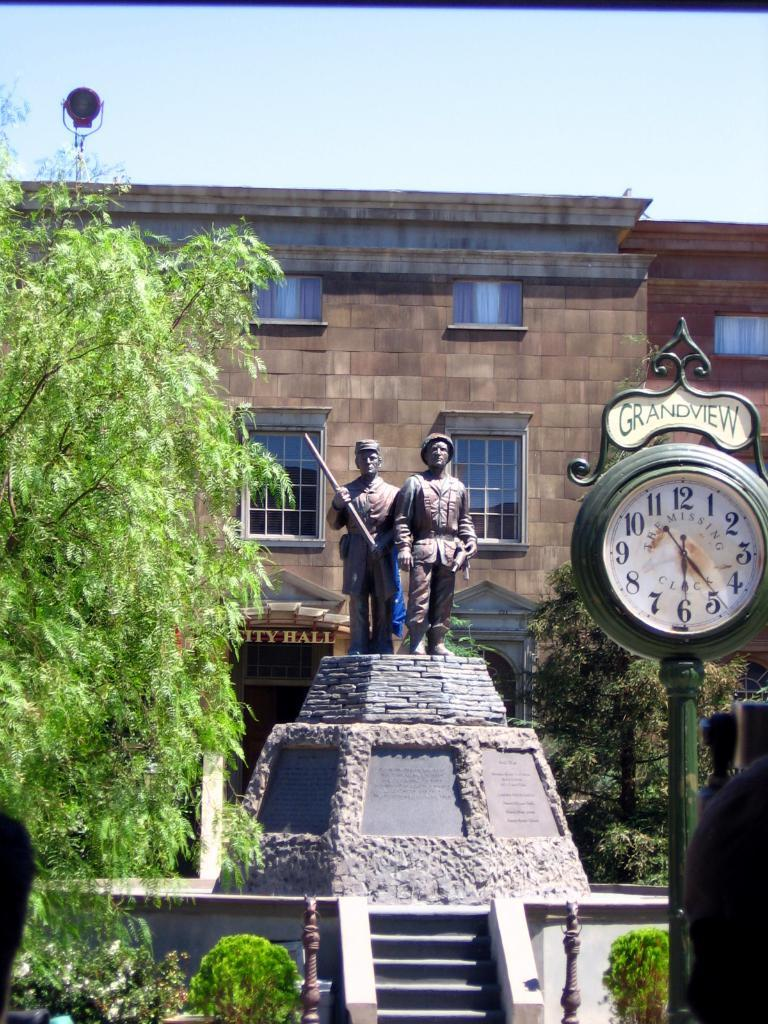<image>
Relay a brief, clear account of the picture shown. the name grandview is on the top of a clock 